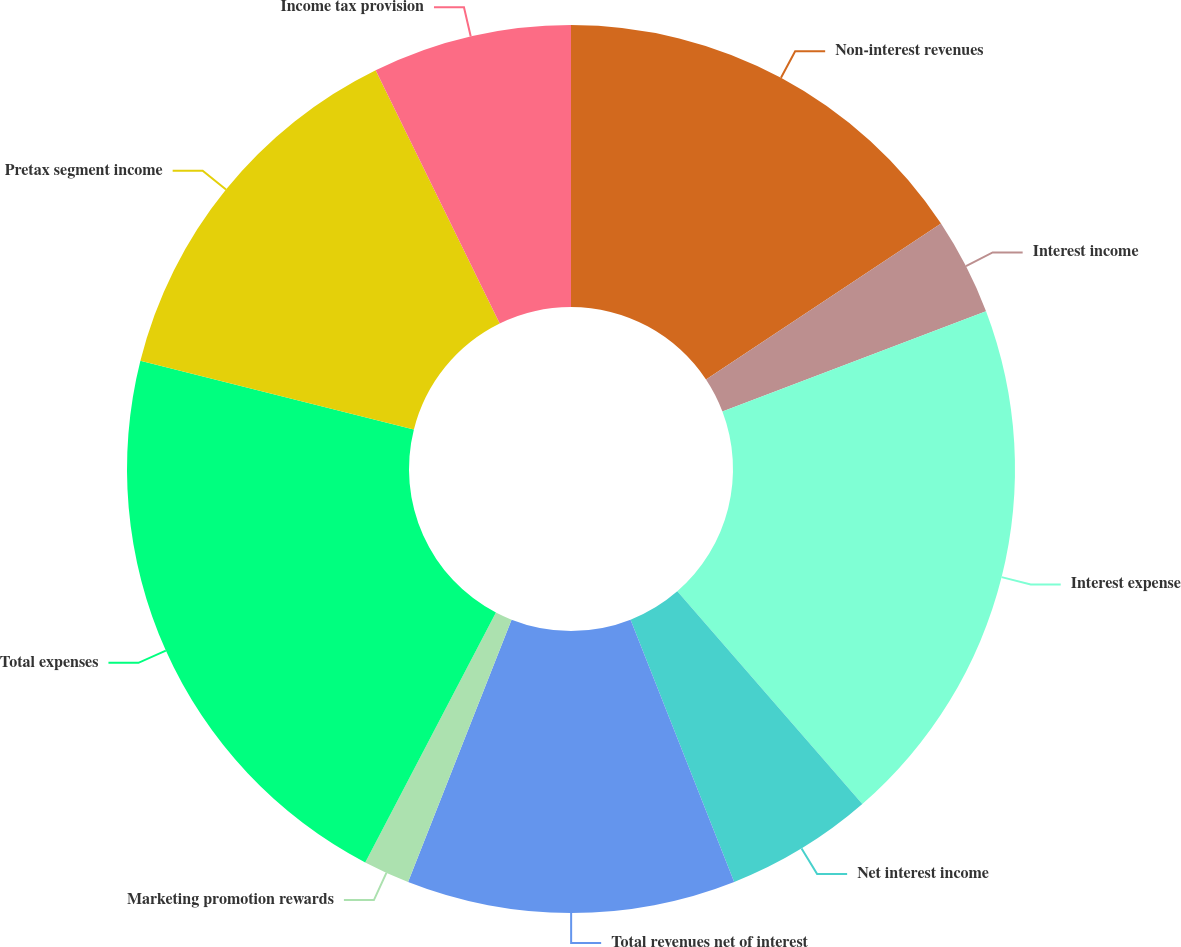<chart> <loc_0><loc_0><loc_500><loc_500><pie_chart><fcel>Non-interest revenues<fcel>Interest income<fcel>Interest expense<fcel>Net interest income<fcel>Total revenues net of interest<fcel>Marketing promotion rewards<fcel>Total expenses<fcel>Pretax segment income<fcel>Income tax provision<nl><fcel>15.68%<fcel>3.54%<fcel>19.39%<fcel>5.4%<fcel>11.97%<fcel>1.69%<fcel>21.25%<fcel>13.83%<fcel>7.25%<nl></chart> 